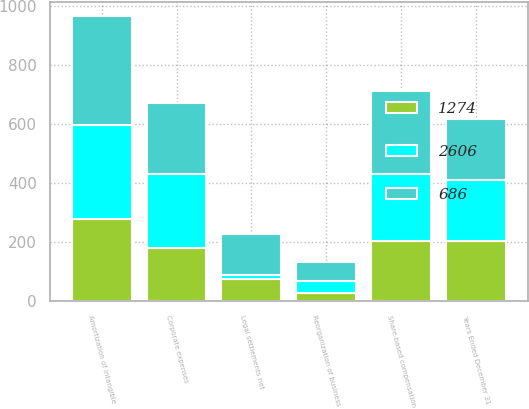Convert chart to OTSL. <chart><loc_0><loc_0><loc_500><loc_500><stacked_bar_chart><ecel><fcel>Years Ended December 31<fcel>Amortization of intangible<fcel>Share-based compensation<fcel>Corporate expenses<fcel>Reorganization of business<fcel>Legal settlements net<nl><fcel>1274<fcel>206<fcel>278<fcel>206<fcel>181<fcel>30<fcel>75<nl><fcel>2606<fcel>206<fcel>318<fcel>224<fcel>252<fcel>38<fcel>14<nl><fcel>686<fcel>206<fcel>369<fcel>284<fcel>240<fcel>64<fcel>140<nl></chart> 